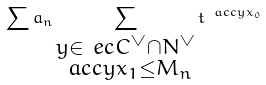Convert formula to latex. <formula><loc_0><loc_0><loc_500><loc_500>\sum a _ { n } \sum _ { \substack { y \in \ e c C ^ { \vee } \cap N ^ { \vee } \\ \ a c c { y } { x _ { 1 } } \leq M _ { n } } } t ^ { \ a c c { y } { x _ { 0 } } }</formula> 